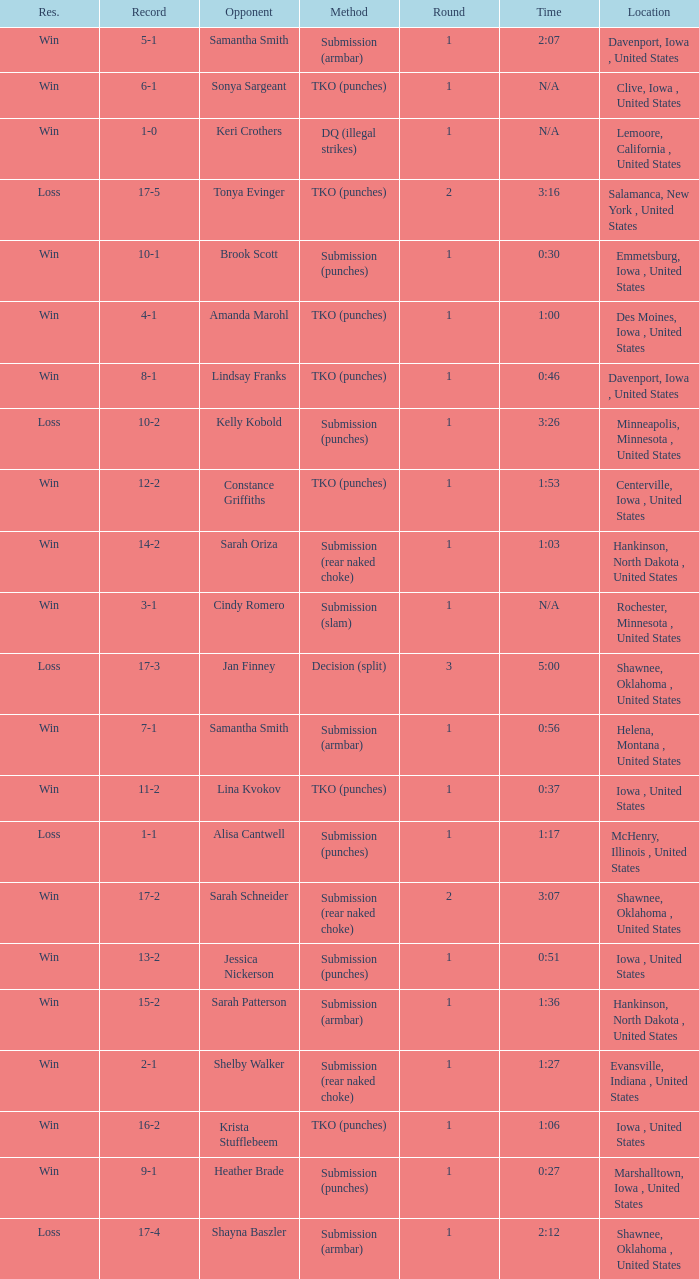What opponent does she fight when she is 10-1? Brook Scott. 